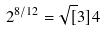<formula> <loc_0><loc_0><loc_500><loc_500>2 ^ { 8 / 1 2 } = \sqrt { [ } 3 ] { 4 }</formula> 